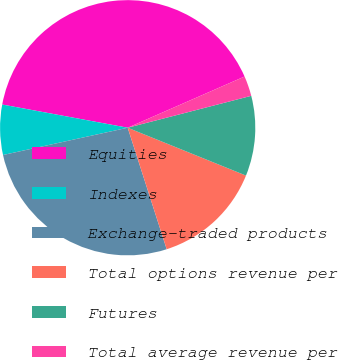<chart> <loc_0><loc_0><loc_500><loc_500><pie_chart><fcel>Equities<fcel>Indexes<fcel>Exchange-traded products<fcel>Total options revenue per<fcel>Futures<fcel>Total average revenue per<nl><fcel>40.52%<fcel>6.34%<fcel>26.52%<fcel>13.94%<fcel>10.14%<fcel>2.55%<nl></chart> 